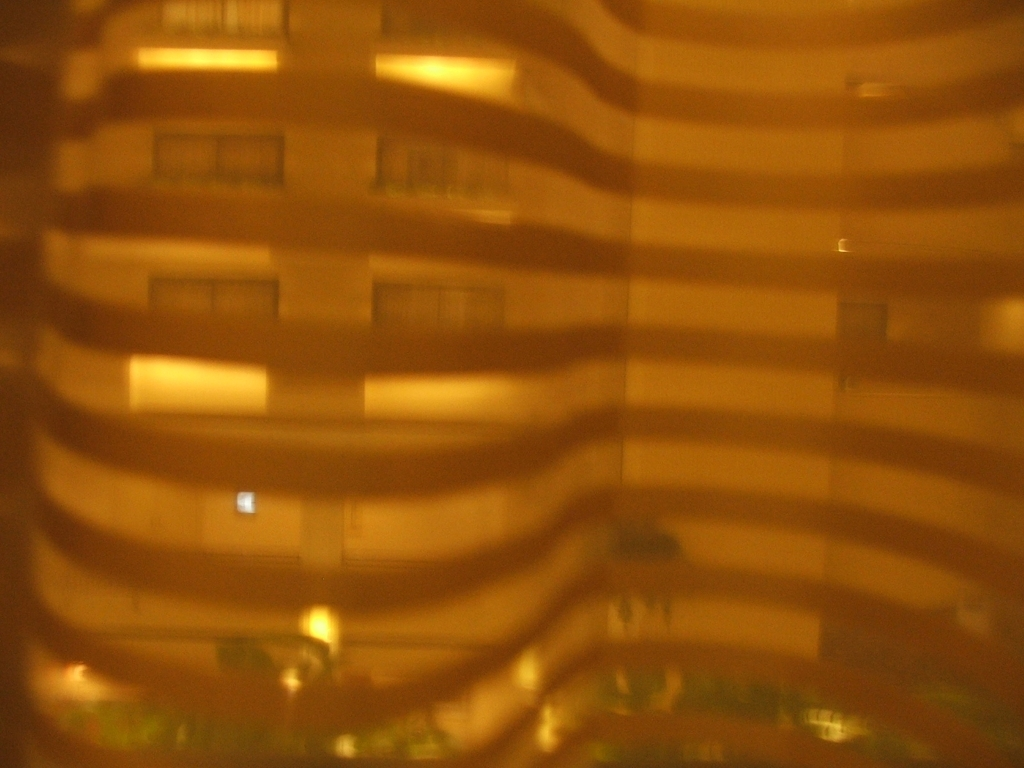What might be the reason for the haziness in the image? The haziness could be due to several factors like condensation on the camera lens, smog or fog in the environment, or a filter applied during post-processing to achieve a certain aesthetic. 